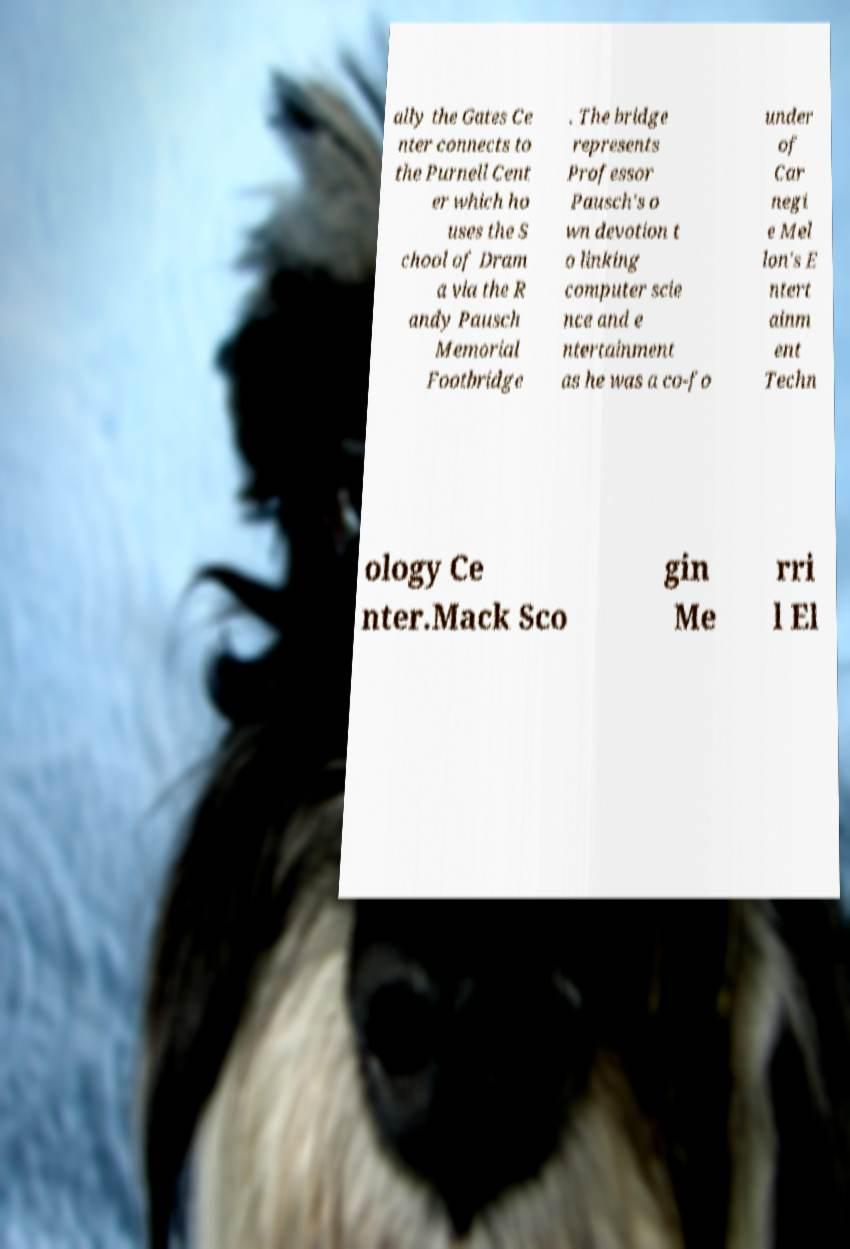Please read and relay the text visible in this image. What does it say? ally the Gates Ce nter connects to the Purnell Cent er which ho uses the S chool of Dram a via the R andy Pausch Memorial Footbridge . The bridge represents Professor Pausch's o wn devotion t o linking computer scie nce and e ntertainment as he was a co-fo under of Car negi e Mel lon's E ntert ainm ent Techn ology Ce nter.Mack Sco gin Me rri l El 